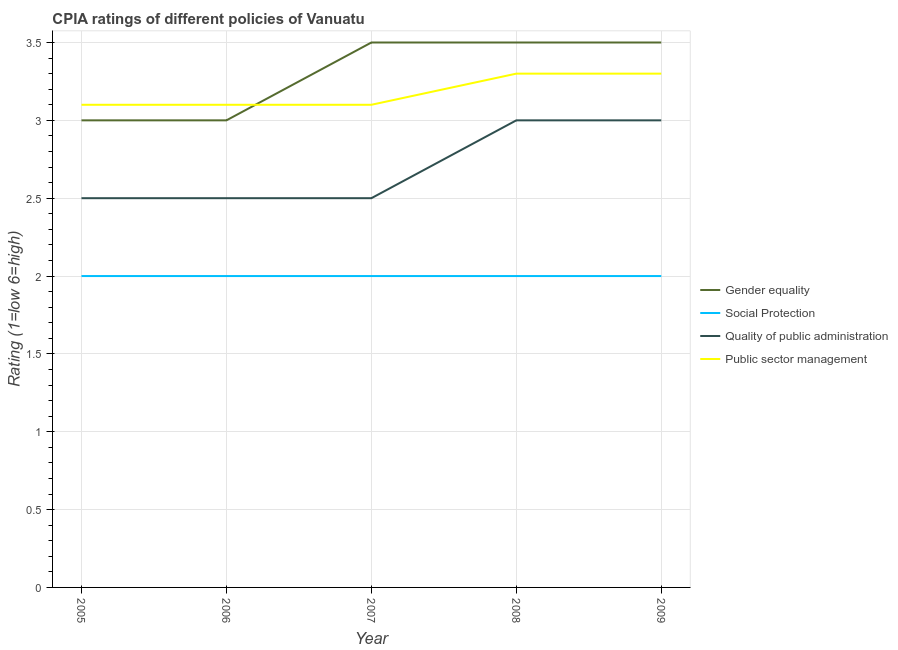Does the line corresponding to cpia rating of gender equality intersect with the line corresponding to cpia rating of quality of public administration?
Offer a very short reply. No. What is the total cpia rating of gender equality in the graph?
Provide a succinct answer. 16.5. What is the difference between the cpia rating of public sector management in 2006 and that in 2009?
Your response must be concise. -0.2. What is the difference between the cpia rating of gender equality in 2007 and the cpia rating of quality of public administration in 2006?
Provide a short and direct response. 1. In the year 2009, what is the difference between the cpia rating of quality of public administration and cpia rating of public sector management?
Your response must be concise. -0.3. In how many years, is the cpia rating of social protection greater than 1?
Make the answer very short. 5. What is the ratio of the cpia rating of gender equality in 2007 to that in 2008?
Your answer should be compact. 1. Is the difference between the cpia rating of social protection in 2005 and 2009 greater than the difference between the cpia rating of quality of public administration in 2005 and 2009?
Provide a short and direct response. Yes. In how many years, is the cpia rating of gender equality greater than the average cpia rating of gender equality taken over all years?
Offer a very short reply. 3. Is the sum of the cpia rating of quality of public administration in 2005 and 2006 greater than the maximum cpia rating of social protection across all years?
Your answer should be compact. Yes. Is it the case that in every year, the sum of the cpia rating of social protection and cpia rating of public sector management is greater than the sum of cpia rating of gender equality and cpia rating of quality of public administration?
Offer a terse response. No. Does the cpia rating of quality of public administration monotonically increase over the years?
Offer a very short reply. No. Is the cpia rating of quality of public administration strictly greater than the cpia rating of social protection over the years?
Offer a terse response. Yes. Is the cpia rating of public sector management strictly less than the cpia rating of social protection over the years?
Offer a terse response. No. What is the difference between two consecutive major ticks on the Y-axis?
Keep it short and to the point. 0.5. Does the graph contain any zero values?
Provide a short and direct response. No. Does the graph contain grids?
Offer a terse response. Yes. Where does the legend appear in the graph?
Ensure brevity in your answer.  Center right. How many legend labels are there?
Keep it short and to the point. 4. What is the title of the graph?
Your answer should be compact. CPIA ratings of different policies of Vanuatu. Does "Business regulatory environment" appear as one of the legend labels in the graph?
Provide a short and direct response. No. What is the label or title of the X-axis?
Your answer should be very brief. Year. What is the Rating (1=low 6=high) of Quality of public administration in 2005?
Offer a very short reply. 2.5. What is the Rating (1=low 6=high) of Social Protection in 2006?
Provide a succinct answer. 2. What is the Rating (1=low 6=high) in Public sector management in 2007?
Offer a very short reply. 3.1. What is the Rating (1=low 6=high) in Gender equality in 2008?
Your response must be concise. 3.5. What is the Rating (1=low 6=high) of Social Protection in 2008?
Offer a very short reply. 2. What is the Rating (1=low 6=high) of Public sector management in 2008?
Provide a short and direct response. 3.3. What is the Rating (1=low 6=high) in Gender equality in 2009?
Your answer should be very brief. 3.5. What is the Rating (1=low 6=high) of Social Protection in 2009?
Offer a very short reply. 2. What is the Rating (1=low 6=high) of Public sector management in 2009?
Keep it short and to the point. 3.3. Across all years, what is the maximum Rating (1=low 6=high) in Social Protection?
Provide a succinct answer. 2. Across all years, what is the maximum Rating (1=low 6=high) in Quality of public administration?
Give a very brief answer. 3. Across all years, what is the minimum Rating (1=low 6=high) in Quality of public administration?
Your response must be concise. 2.5. What is the total Rating (1=low 6=high) in Gender equality in the graph?
Offer a terse response. 16.5. What is the total Rating (1=low 6=high) in Social Protection in the graph?
Offer a very short reply. 10. What is the difference between the Rating (1=low 6=high) of Gender equality in 2005 and that in 2006?
Provide a succinct answer. 0. What is the difference between the Rating (1=low 6=high) of Social Protection in 2005 and that in 2006?
Provide a short and direct response. 0. What is the difference between the Rating (1=low 6=high) of Quality of public administration in 2005 and that in 2006?
Your answer should be compact. 0. What is the difference between the Rating (1=low 6=high) in Gender equality in 2005 and that in 2007?
Offer a terse response. -0.5. What is the difference between the Rating (1=low 6=high) of Social Protection in 2005 and that in 2009?
Keep it short and to the point. 0. What is the difference between the Rating (1=low 6=high) in Quality of public administration in 2005 and that in 2009?
Give a very brief answer. -0.5. What is the difference between the Rating (1=low 6=high) of Public sector management in 2005 and that in 2009?
Offer a very short reply. -0.2. What is the difference between the Rating (1=low 6=high) of Gender equality in 2006 and that in 2007?
Make the answer very short. -0.5. What is the difference between the Rating (1=low 6=high) in Social Protection in 2006 and that in 2007?
Ensure brevity in your answer.  0. What is the difference between the Rating (1=low 6=high) of Public sector management in 2006 and that in 2007?
Give a very brief answer. 0. What is the difference between the Rating (1=low 6=high) of Gender equality in 2006 and that in 2008?
Your response must be concise. -0.5. What is the difference between the Rating (1=low 6=high) in Quality of public administration in 2006 and that in 2008?
Offer a terse response. -0.5. What is the difference between the Rating (1=low 6=high) of Social Protection in 2006 and that in 2009?
Give a very brief answer. 0. What is the difference between the Rating (1=low 6=high) in Quality of public administration in 2006 and that in 2009?
Keep it short and to the point. -0.5. What is the difference between the Rating (1=low 6=high) in Public sector management in 2006 and that in 2009?
Provide a succinct answer. -0.2. What is the difference between the Rating (1=low 6=high) of Social Protection in 2007 and that in 2008?
Give a very brief answer. 0. What is the difference between the Rating (1=low 6=high) in Gender equality in 2007 and that in 2009?
Give a very brief answer. 0. What is the difference between the Rating (1=low 6=high) of Quality of public administration in 2007 and that in 2009?
Ensure brevity in your answer.  -0.5. What is the difference between the Rating (1=low 6=high) of Gender equality in 2008 and that in 2009?
Provide a short and direct response. 0. What is the difference between the Rating (1=low 6=high) of Quality of public administration in 2008 and that in 2009?
Your answer should be very brief. 0. What is the difference between the Rating (1=low 6=high) in Social Protection in 2005 and the Rating (1=low 6=high) in Quality of public administration in 2006?
Your answer should be compact. -0.5. What is the difference between the Rating (1=low 6=high) of Social Protection in 2005 and the Rating (1=low 6=high) of Public sector management in 2006?
Make the answer very short. -1.1. What is the difference between the Rating (1=low 6=high) in Quality of public administration in 2005 and the Rating (1=low 6=high) in Public sector management in 2006?
Your response must be concise. -0.6. What is the difference between the Rating (1=low 6=high) in Social Protection in 2005 and the Rating (1=low 6=high) in Quality of public administration in 2007?
Offer a very short reply. -0.5. What is the difference between the Rating (1=low 6=high) of Social Protection in 2005 and the Rating (1=low 6=high) of Public sector management in 2007?
Give a very brief answer. -1.1. What is the difference between the Rating (1=low 6=high) of Quality of public administration in 2005 and the Rating (1=low 6=high) of Public sector management in 2007?
Offer a terse response. -0.6. What is the difference between the Rating (1=low 6=high) of Gender equality in 2005 and the Rating (1=low 6=high) of Social Protection in 2008?
Make the answer very short. 1. What is the difference between the Rating (1=low 6=high) of Social Protection in 2005 and the Rating (1=low 6=high) of Public sector management in 2008?
Provide a short and direct response. -1.3. What is the difference between the Rating (1=low 6=high) of Quality of public administration in 2005 and the Rating (1=low 6=high) of Public sector management in 2008?
Make the answer very short. -0.8. What is the difference between the Rating (1=low 6=high) in Gender equality in 2005 and the Rating (1=low 6=high) in Social Protection in 2009?
Your answer should be very brief. 1. What is the difference between the Rating (1=low 6=high) in Gender equality in 2005 and the Rating (1=low 6=high) in Quality of public administration in 2009?
Your response must be concise. 0. What is the difference between the Rating (1=low 6=high) of Gender equality in 2005 and the Rating (1=low 6=high) of Public sector management in 2009?
Ensure brevity in your answer.  -0.3. What is the difference between the Rating (1=low 6=high) in Social Protection in 2005 and the Rating (1=low 6=high) in Quality of public administration in 2009?
Keep it short and to the point. -1. What is the difference between the Rating (1=low 6=high) in Social Protection in 2005 and the Rating (1=low 6=high) in Public sector management in 2009?
Provide a short and direct response. -1.3. What is the difference between the Rating (1=low 6=high) of Gender equality in 2006 and the Rating (1=low 6=high) of Quality of public administration in 2007?
Ensure brevity in your answer.  0.5. What is the difference between the Rating (1=low 6=high) of Gender equality in 2006 and the Rating (1=low 6=high) of Public sector management in 2007?
Keep it short and to the point. -0.1. What is the difference between the Rating (1=low 6=high) of Social Protection in 2006 and the Rating (1=low 6=high) of Public sector management in 2007?
Your answer should be very brief. -1.1. What is the difference between the Rating (1=low 6=high) in Gender equality in 2006 and the Rating (1=low 6=high) in Public sector management in 2008?
Ensure brevity in your answer.  -0.3. What is the difference between the Rating (1=low 6=high) in Social Protection in 2006 and the Rating (1=low 6=high) in Quality of public administration in 2008?
Make the answer very short. -1. What is the difference between the Rating (1=low 6=high) of Social Protection in 2006 and the Rating (1=low 6=high) of Public sector management in 2008?
Offer a terse response. -1.3. What is the difference between the Rating (1=low 6=high) in Quality of public administration in 2006 and the Rating (1=low 6=high) in Public sector management in 2008?
Your answer should be compact. -0.8. What is the difference between the Rating (1=low 6=high) in Gender equality in 2006 and the Rating (1=low 6=high) in Quality of public administration in 2009?
Provide a succinct answer. 0. What is the difference between the Rating (1=low 6=high) in Social Protection in 2006 and the Rating (1=low 6=high) in Public sector management in 2009?
Offer a very short reply. -1.3. What is the difference between the Rating (1=low 6=high) in Gender equality in 2007 and the Rating (1=low 6=high) in Social Protection in 2008?
Provide a short and direct response. 1.5. What is the difference between the Rating (1=low 6=high) of Gender equality in 2007 and the Rating (1=low 6=high) of Quality of public administration in 2008?
Ensure brevity in your answer.  0.5. What is the difference between the Rating (1=low 6=high) in Gender equality in 2007 and the Rating (1=low 6=high) in Public sector management in 2008?
Offer a terse response. 0.2. What is the difference between the Rating (1=low 6=high) of Social Protection in 2007 and the Rating (1=low 6=high) of Quality of public administration in 2008?
Your answer should be very brief. -1. What is the difference between the Rating (1=low 6=high) in Social Protection in 2007 and the Rating (1=low 6=high) in Public sector management in 2008?
Provide a short and direct response. -1.3. What is the difference between the Rating (1=low 6=high) of Quality of public administration in 2007 and the Rating (1=low 6=high) of Public sector management in 2008?
Offer a terse response. -0.8. What is the difference between the Rating (1=low 6=high) in Gender equality in 2007 and the Rating (1=low 6=high) in Social Protection in 2009?
Your answer should be compact. 1.5. What is the difference between the Rating (1=low 6=high) of Gender equality in 2007 and the Rating (1=low 6=high) of Public sector management in 2009?
Provide a succinct answer. 0.2. What is the difference between the Rating (1=low 6=high) of Social Protection in 2007 and the Rating (1=low 6=high) of Quality of public administration in 2009?
Give a very brief answer. -1. What is the difference between the Rating (1=low 6=high) of Social Protection in 2007 and the Rating (1=low 6=high) of Public sector management in 2009?
Offer a terse response. -1.3. What is the difference between the Rating (1=low 6=high) in Quality of public administration in 2007 and the Rating (1=low 6=high) in Public sector management in 2009?
Provide a succinct answer. -0.8. What is the difference between the Rating (1=low 6=high) in Gender equality in 2008 and the Rating (1=low 6=high) in Public sector management in 2009?
Provide a succinct answer. 0.2. What is the difference between the Rating (1=low 6=high) of Social Protection in 2008 and the Rating (1=low 6=high) of Public sector management in 2009?
Your answer should be compact. -1.3. What is the average Rating (1=low 6=high) in Gender equality per year?
Provide a short and direct response. 3.3. What is the average Rating (1=low 6=high) in Public sector management per year?
Ensure brevity in your answer.  3.18. In the year 2005, what is the difference between the Rating (1=low 6=high) in Gender equality and Rating (1=low 6=high) in Quality of public administration?
Ensure brevity in your answer.  0.5. In the year 2005, what is the difference between the Rating (1=low 6=high) of Gender equality and Rating (1=low 6=high) of Public sector management?
Offer a terse response. -0.1. In the year 2005, what is the difference between the Rating (1=low 6=high) of Social Protection and Rating (1=low 6=high) of Quality of public administration?
Your response must be concise. -0.5. In the year 2005, what is the difference between the Rating (1=low 6=high) in Quality of public administration and Rating (1=low 6=high) in Public sector management?
Offer a terse response. -0.6. In the year 2006, what is the difference between the Rating (1=low 6=high) in Gender equality and Rating (1=low 6=high) in Social Protection?
Your response must be concise. 1. In the year 2006, what is the difference between the Rating (1=low 6=high) in Gender equality and Rating (1=low 6=high) in Quality of public administration?
Offer a very short reply. 0.5. In the year 2006, what is the difference between the Rating (1=low 6=high) of Social Protection and Rating (1=low 6=high) of Quality of public administration?
Your answer should be compact. -0.5. In the year 2007, what is the difference between the Rating (1=low 6=high) in Gender equality and Rating (1=low 6=high) in Social Protection?
Your answer should be compact. 1.5. In the year 2007, what is the difference between the Rating (1=low 6=high) of Gender equality and Rating (1=low 6=high) of Quality of public administration?
Provide a succinct answer. 1. In the year 2007, what is the difference between the Rating (1=low 6=high) in Social Protection and Rating (1=low 6=high) in Quality of public administration?
Make the answer very short. -0.5. In the year 2007, what is the difference between the Rating (1=low 6=high) of Social Protection and Rating (1=low 6=high) of Public sector management?
Provide a short and direct response. -1.1. In the year 2008, what is the difference between the Rating (1=low 6=high) in Gender equality and Rating (1=low 6=high) in Social Protection?
Provide a short and direct response. 1.5. In the year 2008, what is the difference between the Rating (1=low 6=high) of Gender equality and Rating (1=low 6=high) of Quality of public administration?
Keep it short and to the point. 0.5. In the year 2008, what is the difference between the Rating (1=low 6=high) of Gender equality and Rating (1=low 6=high) of Public sector management?
Give a very brief answer. 0.2. In the year 2008, what is the difference between the Rating (1=low 6=high) of Social Protection and Rating (1=low 6=high) of Quality of public administration?
Your response must be concise. -1. In the year 2008, what is the difference between the Rating (1=low 6=high) of Social Protection and Rating (1=low 6=high) of Public sector management?
Give a very brief answer. -1.3. In the year 2009, what is the difference between the Rating (1=low 6=high) of Gender equality and Rating (1=low 6=high) of Social Protection?
Make the answer very short. 1.5. In the year 2009, what is the difference between the Rating (1=low 6=high) of Gender equality and Rating (1=low 6=high) of Quality of public administration?
Offer a terse response. 0.5. In the year 2009, what is the difference between the Rating (1=low 6=high) in Gender equality and Rating (1=low 6=high) in Public sector management?
Keep it short and to the point. 0.2. What is the ratio of the Rating (1=low 6=high) in Quality of public administration in 2005 to that in 2006?
Offer a terse response. 1. What is the ratio of the Rating (1=low 6=high) in Public sector management in 2005 to that in 2006?
Offer a very short reply. 1. What is the ratio of the Rating (1=low 6=high) in Gender equality in 2005 to that in 2007?
Make the answer very short. 0.86. What is the ratio of the Rating (1=low 6=high) in Quality of public administration in 2005 to that in 2007?
Your response must be concise. 1. What is the ratio of the Rating (1=low 6=high) in Public sector management in 2005 to that in 2007?
Keep it short and to the point. 1. What is the ratio of the Rating (1=low 6=high) in Social Protection in 2005 to that in 2008?
Your answer should be very brief. 1. What is the ratio of the Rating (1=low 6=high) of Public sector management in 2005 to that in 2008?
Offer a very short reply. 0.94. What is the ratio of the Rating (1=low 6=high) of Gender equality in 2005 to that in 2009?
Your response must be concise. 0.86. What is the ratio of the Rating (1=low 6=high) in Social Protection in 2005 to that in 2009?
Provide a succinct answer. 1. What is the ratio of the Rating (1=low 6=high) of Quality of public administration in 2005 to that in 2009?
Offer a very short reply. 0.83. What is the ratio of the Rating (1=low 6=high) of Public sector management in 2005 to that in 2009?
Give a very brief answer. 0.94. What is the ratio of the Rating (1=low 6=high) of Quality of public administration in 2006 to that in 2007?
Give a very brief answer. 1. What is the ratio of the Rating (1=low 6=high) in Social Protection in 2006 to that in 2008?
Give a very brief answer. 1. What is the ratio of the Rating (1=low 6=high) in Public sector management in 2006 to that in 2008?
Provide a succinct answer. 0.94. What is the ratio of the Rating (1=low 6=high) of Quality of public administration in 2006 to that in 2009?
Make the answer very short. 0.83. What is the ratio of the Rating (1=low 6=high) of Public sector management in 2006 to that in 2009?
Make the answer very short. 0.94. What is the ratio of the Rating (1=low 6=high) in Social Protection in 2007 to that in 2008?
Your answer should be very brief. 1. What is the ratio of the Rating (1=low 6=high) of Public sector management in 2007 to that in 2008?
Keep it short and to the point. 0.94. What is the ratio of the Rating (1=low 6=high) in Gender equality in 2007 to that in 2009?
Ensure brevity in your answer.  1. What is the ratio of the Rating (1=low 6=high) of Social Protection in 2007 to that in 2009?
Provide a succinct answer. 1. What is the ratio of the Rating (1=low 6=high) in Quality of public administration in 2007 to that in 2009?
Offer a very short reply. 0.83. What is the ratio of the Rating (1=low 6=high) of Public sector management in 2007 to that in 2009?
Give a very brief answer. 0.94. What is the ratio of the Rating (1=low 6=high) of Quality of public administration in 2008 to that in 2009?
Provide a succinct answer. 1. What is the ratio of the Rating (1=low 6=high) in Public sector management in 2008 to that in 2009?
Provide a succinct answer. 1. What is the difference between the highest and the lowest Rating (1=low 6=high) in Gender equality?
Give a very brief answer. 0.5. What is the difference between the highest and the lowest Rating (1=low 6=high) of Quality of public administration?
Ensure brevity in your answer.  0.5. 